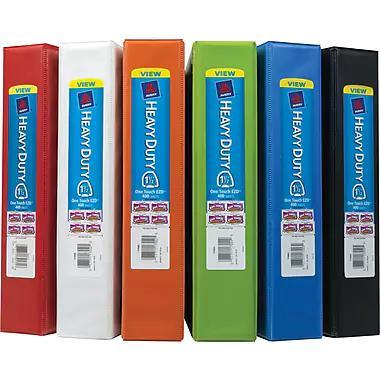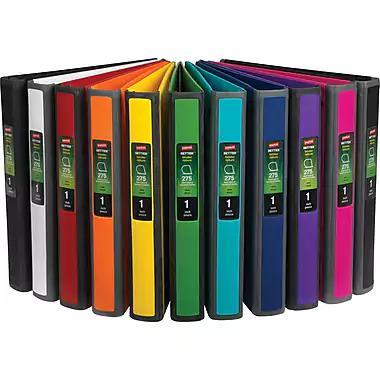The first image is the image on the left, the second image is the image on the right. Given the left and right images, does the statement "In one of the pictures, the white binder is between the black and red binders." hold true? Answer yes or no. Yes. The first image is the image on the left, the second image is the image on the right. Assess this claim about the two images: "One image shows different colored binders displayed at some angle, instead of curved or straight ahead.". Correct or not? Answer yes or no. No. 